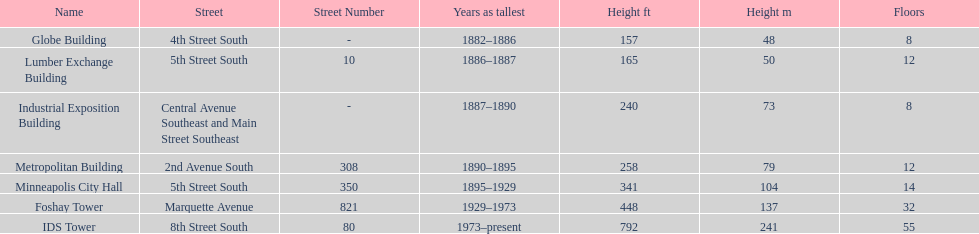How long did the lumber exchange building stand as the tallest building? 1 year. 